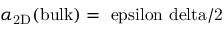<formula> <loc_0><loc_0><loc_500><loc_500>\alpha _ { 2 D } ( b u l k ) = \ e p s i l o n \ d e l t a / 2</formula> 